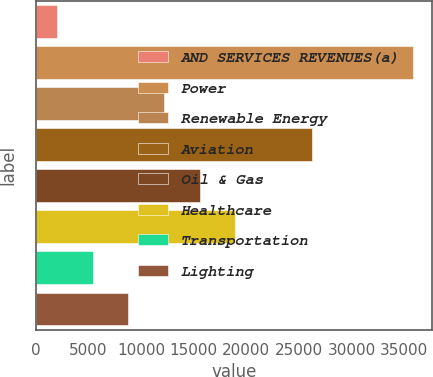Convert chart to OTSL. <chart><loc_0><loc_0><loc_500><loc_500><bar_chart><fcel>AND SERVICES REVENUES(a)<fcel>Power<fcel>Renewable Energy<fcel>Aviation<fcel>Oil & Gas<fcel>Healthcare<fcel>Transportation<fcel>Lighting<nl><fcel>2016<fcel>35835<fcel>12161.7<fcel>26240<fcel>15543.6<fcel>18925.5<fcel>5397.9<fcel>8779.8<nl></chart> 